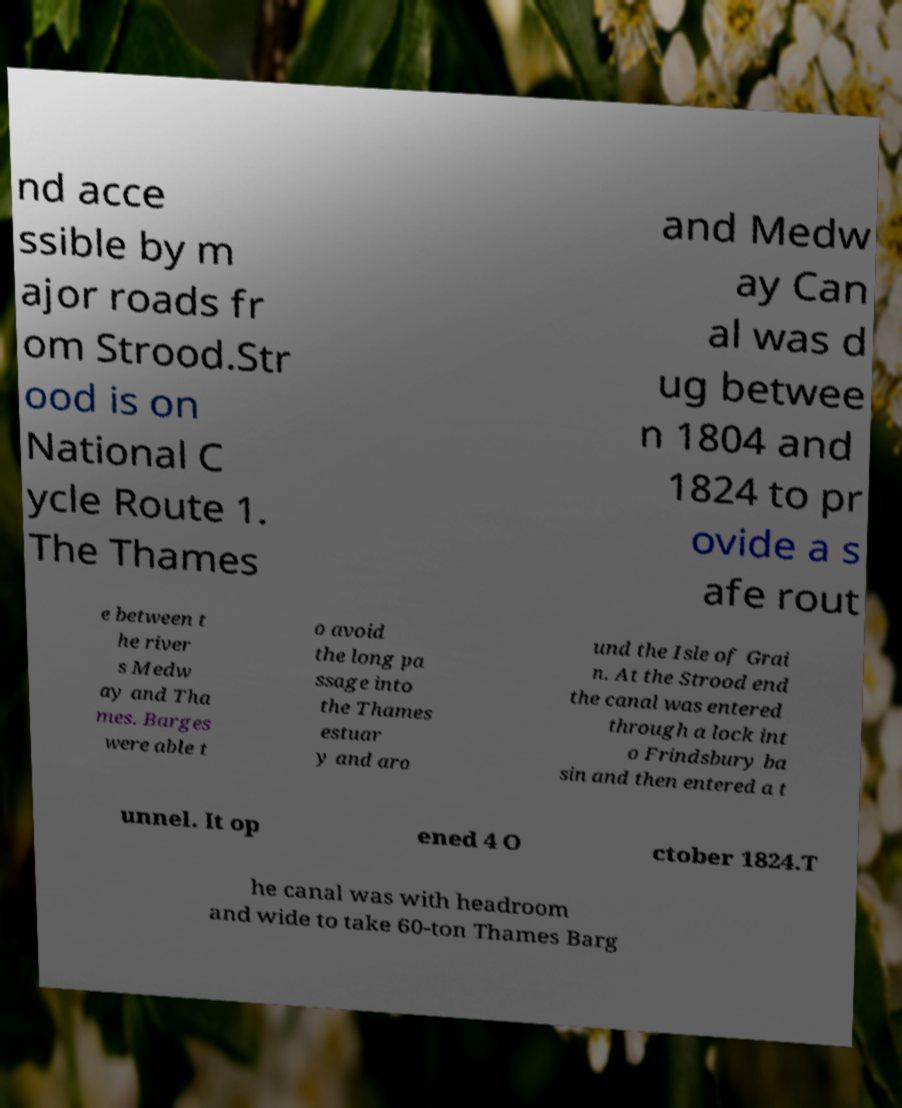There's text embedded in this image that I need extracted. Can you transcribe it verbatim? nd acce ssible by m ajor roads fr om Strood.Str ood is on National C ycle Route 1. The Thames and Medw ay Can al was d ug betwee n 1804 and 1824 to pr ovide a s afe rout e between t he river s Medw ay and Tha mes. Barges were able t o avoid the long pa ssage into the Thames estuar y and aro und the Isle of Grai n. At the Strood end the canal was entered through a lock int o Frindsbury ba sin and then entered a t unnel. It op ened 4 O ctober 1824.T he canal was with headroom and wide to take 60-ton Thames Barg 